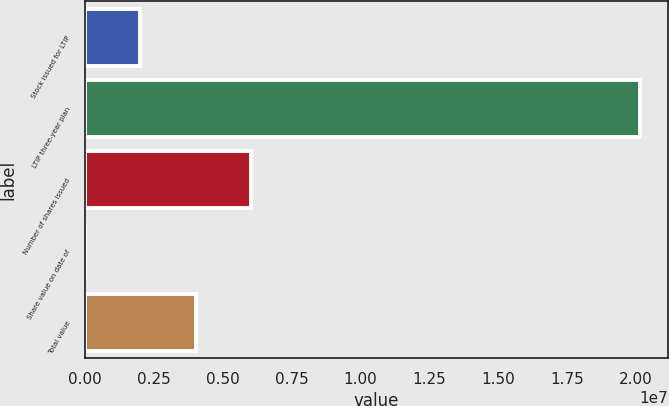Convert chart to OTSL. <chart><loc_0><loc_0><loc_500><loc_500><bar_chart><fcel>Stock issued for LTIP<fcel>LTIP three-year plan<fcel>Number of shares issued<fcel>Share value on date of<fcel>Total value<nl><fcel>2.01429e+06<fcel>2.01415e+07<fcel>6.04256e+06<fcel>157.07<fcel>4.02843e+06<nl></chart> 